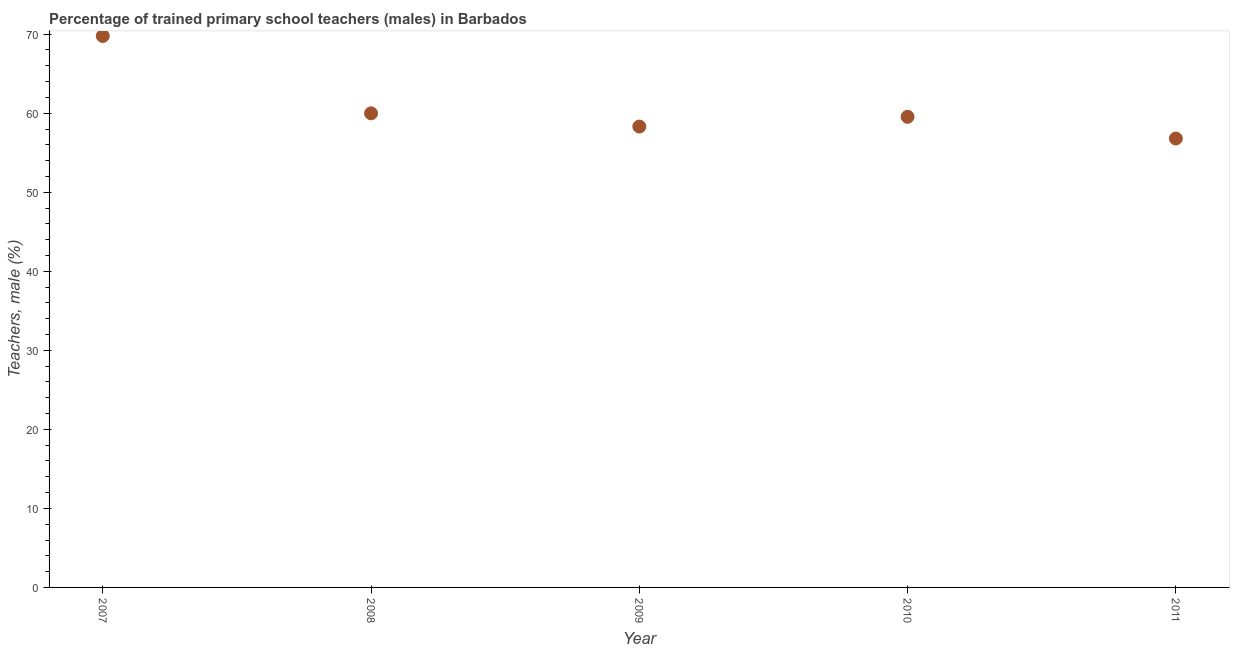What is the percentage of trained male teachers in 2008?
Your response must be concise. 59.99. Across all years, what is the maximum percentage of trained male teachers?
Offer a terse response. 69.78. Across all years, what is the minimum percentage of trained male teachers?
Offer a terse response. 56.8. In which year was the percentage of trained male teachers minimum?
Offer a terse response. 2011. What is the sum of the percentage of trained male teachers?
Offer a very short reply. 304.42. What is the difference between the percentage of trained male teachers in 2008 and 2010?
Your response must be concise. 0.44. What is the average percentage of trained male teachers per year?
Keep it short and to the point. 60.88. What is the median percentage of trained male teachers?
Offer a terse response. 59.55. In how many years, is the percentage of trained male teachers greater than 18 %?
Provide a short and direct response. 5. Do a majority of the years between 2011 and 2007 (inclusive) have percentage of trained male teachers greater than 28 %?
Your answer should be compact. Yes. What is the ratio of the percentage of trained male teachers in 2007 to that in 2009?
Give a very brief answer. 1.2. Is the percentage of trained male teachers in 2007 less than that in 2011?
Provide a succinct answer. No. Is the difference between the percentage of trained male teachers in 2007 and 2008 greater than the difference between any two years?
Your response must be concise. No. What is the difference between the highest and the second highest percentage of trained male teachers?
Offer a terse response. 9.79. What is the difference between the highest and the lowest percentage of trained male teachers?
Offer a terse response. 12.98. In how many years, is the percentage of trained male teachers greater than the average percentage of trained male teachers taken over all years?
Offer a terse response. 1. Does the percentage of trained male teachers monotonically increase over the years?
Provide a short and direct response. No. Are the values on the major ticks of Y-axis written in scientific E-notation?
Ensure brevity in your answer.  No. Does the graph contain grids?
Give a very brief answer. No. What is the title of the graph?
Your answer should be compact. Percentage of trained primary school teachers (males) in Barbados. What is the label or title of the Y-axis?
Your response must be concise. Teachers, male (%). What is the Teachers, male (%) in 2007?
Make the answer very short. 69.78. What is the Teachers, male (%) in 2008?
Make the answer very short. 59.99. What is the Teachers, male (%) in 2009?
Make the answer very short. 58.31. What is the Teachers, male (%) in 2010?
Give a very brief answer. 59.55. What is the Teachers, male (%) in 2011?
Your response must be concise. 56.8. What is the difference between the Teachers, male (%) in 2007 and 2008?
Offer a terse response. 9.79. What is the difference between the Teachers, male (%) in 2007 and 2009?
Give a very brief answer. 11.46. What is the difference between the Teachers, male (%) in 2007 and 2010?
Give a very brief answer. 10.23. What is the difference between the Teachers, male (%) in 2007 and 2011?
Provide a succinct answer. 12.98. What is the difference between the Teachers, male (%) in 2008 and 2009?
Ensure brevity in your answer.  1.67. What is the difference between the Teachers, male (%) in 2008 and 2010?
Offer a very short reply. 0.44. What is the difference between the Teachers, male (%) in 2008 and 2011?
Offer a very short reply. 3.18. What is the difference between the Teachers, male (%) in 2009 and 2010?
Your answer should be very brief. -1.23. What is the difference between the Teachers, male (%) in 2009 and 2011?
Provide a succinct answer. 1.51. What is the difference between the Teachers, male (%) in 2010 and 2011?
Your response must be concise. 2.75. What is the ratio of the Teachers, male (%) in 2007 to that in 2008?
Your answer should be very brief. 1.16. What is the ratio of the Teachers, male (%) in 2007 to that in 2009?
Offer a terse response. 1.2. What is the ratio of the Teachers, male (%) in 2007 to that in 2010?
Provide a succinct answer. 1.17. What is the ratio of the Teachers, male (%) in 2007 to that in 2011?
Keep it short and to the point. 1.23. What is the ratio of the Teachers, male (%) in 2008 to that in 2010?
Your answer should be compact. 1.01. What is the ratio of the Teachers, male (%) in 2008 to that in 2011?
Provide a succinct answer. 1.06. What is the ratio of the Teachers, male (%) in 2009 to that in 2010?
Provide a succinct answer. 0.98. What is the ratio of the Teachers, male (%) in 2010 to that in 2011?
Offer a very short reply. 1.05. 